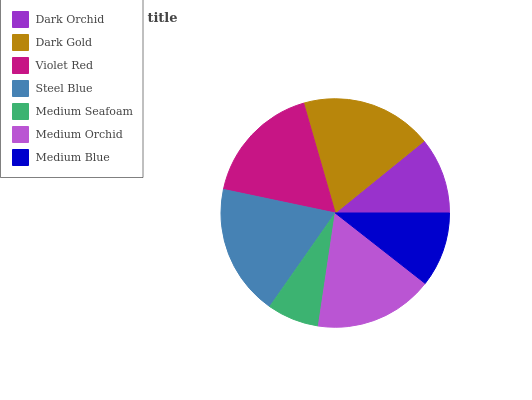Is Medium Seafoam the minimum?
Answer yes or no. Yes. Is Dark Gold the maximum?
Answer yes or no. Yes. Is Violet Red the minimum?
Answer yes or no. No. Is Violet Red the maximum?
Answer yes or no. No. Is Dark Gold greater than Violet Red?
Answer yes or no. Yes. Is Violet Red less than Dark Gold?
Answer yes or no. Yes. Is Violet Red greater than Dark Gold?
Answer yes or no. No. Is Dark Gold less than Violet Red?
Answer yes or no. No. Is Medium Orchid the high median?
Answer yes or no. Yes. Is Medium Orchid the low median?
Answer yes or no. Yes. Is Medium Seafoam the high median?
Answer yes or no. No. Is Dark Gold the low median?
Answer yes or no. No. 